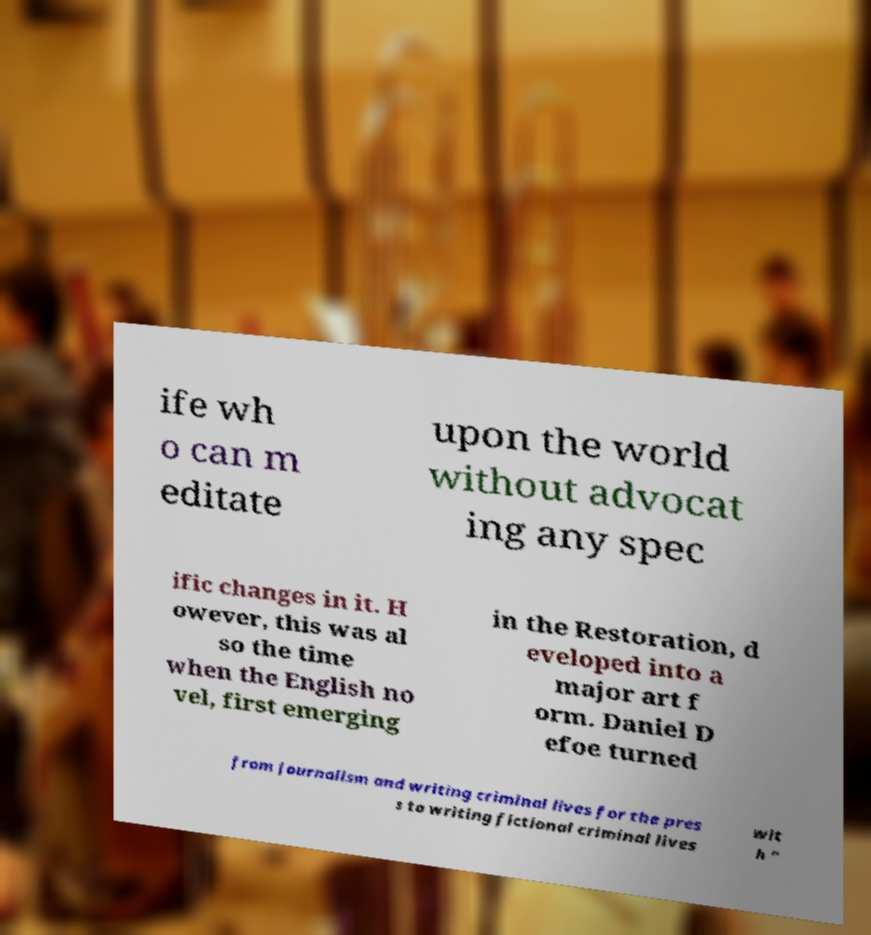I need the written content from this picture converted into text. Can you do that? ife wh o can m editate upon the world without advocat ing any spec ific changes in it. H owever, this was al so the time when the English no vel, first emerging in the Restoration, d eveloped into a major art f orm. Daniel D efoe turned from journalism and writing criminal lives for the pres s to writing fictional criminal lives wit h " 